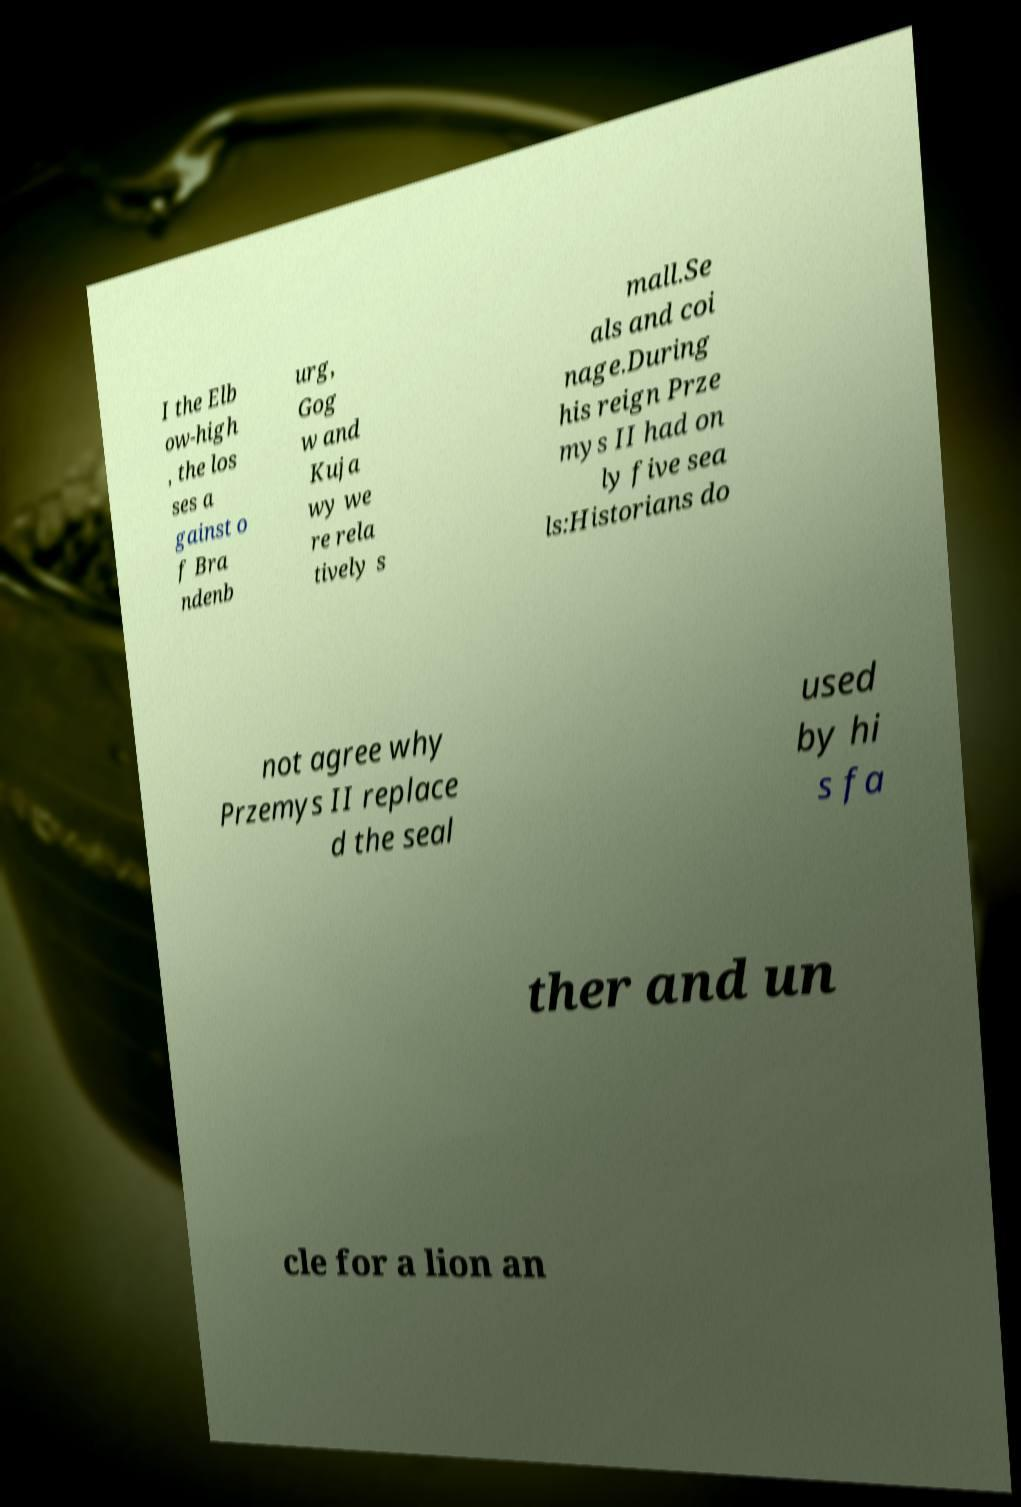Can you accurately transcribe the text from the provided image for me? I the Elb ow-high , the los ses a gainst o f Bra ndenb urg, Gog w and Kuja wy we re rela tively s mall.Se als and coi nage.During his reign Prze mys II had on ly five sea ls:Historians do not agree why Przemys II replace d the seal used by hi s fa ther and un cle for a lion an 